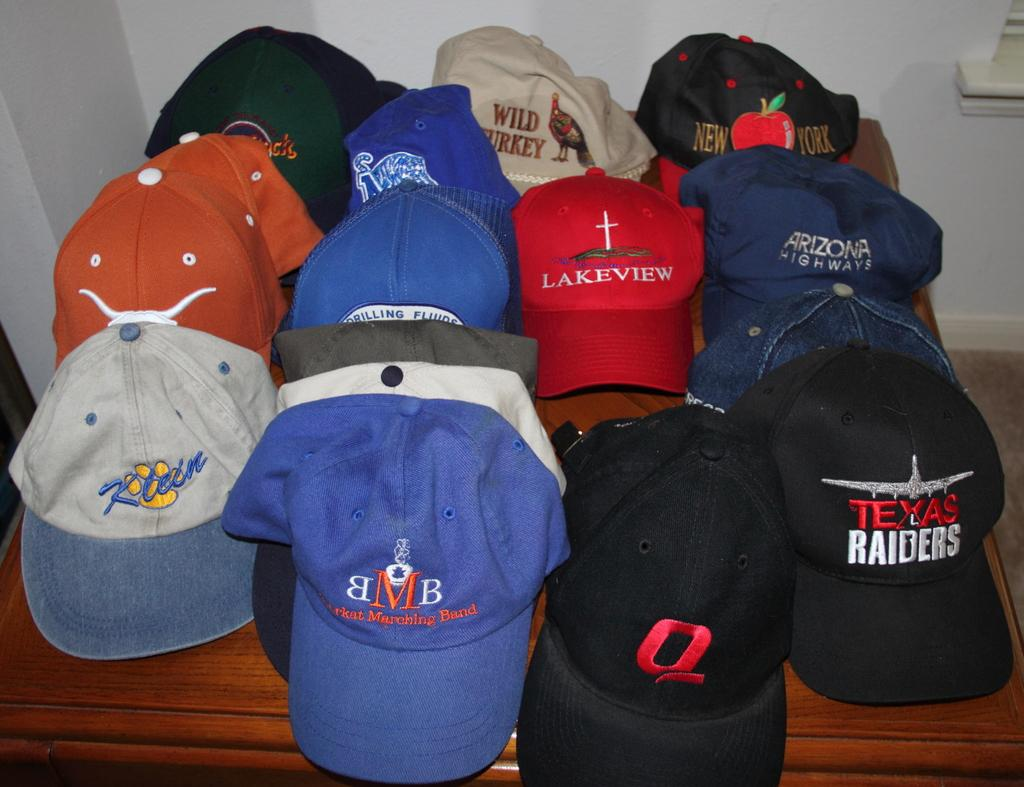What is the color of the wall in the image? The wall in the image is white. What piece of furniture is present in the image? There is a table in the image. What objects are on the table in the image? There are different colored caps on the table. What type of health supplement is on the table in the image? There is no health supplement present in the image; it features a white wall, a table, and different colored caps. 